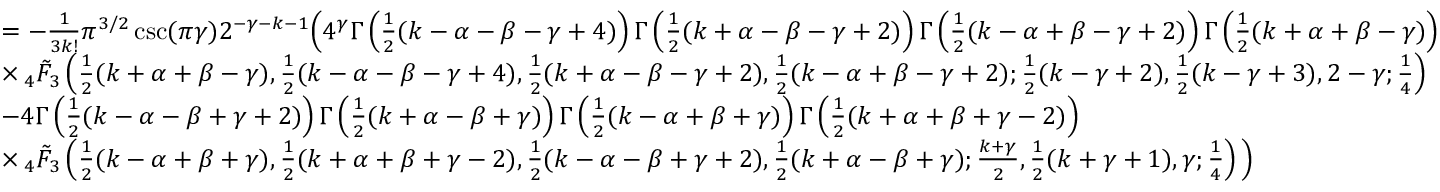Convert formula to latex. <formula><loc_0><loc_0><loc_500><loc_500>\begin{array} { r l } & { = - \frac { 1 } { 3 k ! } \pi ^ { 3 / 2 } \csc ( \pi \gamma ) 2 ^ { - \gamma - k - 1 } \left ( 4 ^ { \gamma } \Gamma \left ( \frac { 1 } { 2 } ( k - \alpha - \beta - \gamma + 4 ) \right ) \Gamma \left ( \frac { 1 } { 2 } ( k + \alpha - \beta - \gamma + 2 ) \right ) \Gamma \left ( \frac { 1 } { 2 } ( k - \alpha + \beta - \gamma + 2 ) \right ) \Gamma \left ( \frac { 1 } { 2 } ( k + \alpha + \beta - \gamma ) \right ) } \\ & { \times \, _ { 4 } \tilde { F } _ { 3 } \left ( \frac { 1 } { 2 } ( k + \alpha + \beta - \gamma ) , \frac { 1 } { 2 } ( k - \alpha - \beta - \gamma + 4 ) , \frac { 1 } { 2 } ( k + \alpha - \beta - \gamma + 2 ) , \frac { 1 } { 2 } ( k - \alpha + \beta - \gamma + 2 ) ; \frac { 1 } { 2 } ( k - \gamma + 2 ) , \frac { 1 } { 2 } ( k - \gamma + 3 ) , 2 - \gamma ; \frac { 1 } { 4 } \right ) } \\ & { - 4 \Gamma \left ( \frac { 1 } { 2 } ( k - \alpha - \beta + \gamma + 2 ) \right ) \Gamma \left ( \frac { 1 } { 2 } ( k + \alpha - \beta + \gamma ) \right ) \Gamma \left ( \frac { 1 } { 2 } ( k - \alpha + \beta + \gamma ) \right ) \Gamma \left ( \frac { 1 } { 2 } ( k + \alpha + \beta + \gamma - 2 ) \right ) } \\ & { \times \, _ { 4 } \tilde { F } _ { 3 } \left ( \frac { 1 } { 2 } ( k - \alpha + \beta + \gamma ) , \frac { 1 } { 2 } ( k + \alpha + \beta + \gamma - 2 ) , \frac { 1 } { 2 } ( k - \alpha - \beta + \gamma + 2 ) , \frac { 1 } { 2 } ( k + \alpha - \beta + \gamma ) ; \frac { k + \gamma } { 2 } , \frac { 1 } { 2 } ( k + \gamma + 1 ) , \gamma ; \frac { 1 } { 4 } \right ) \right ) } \end{array}</formula> 